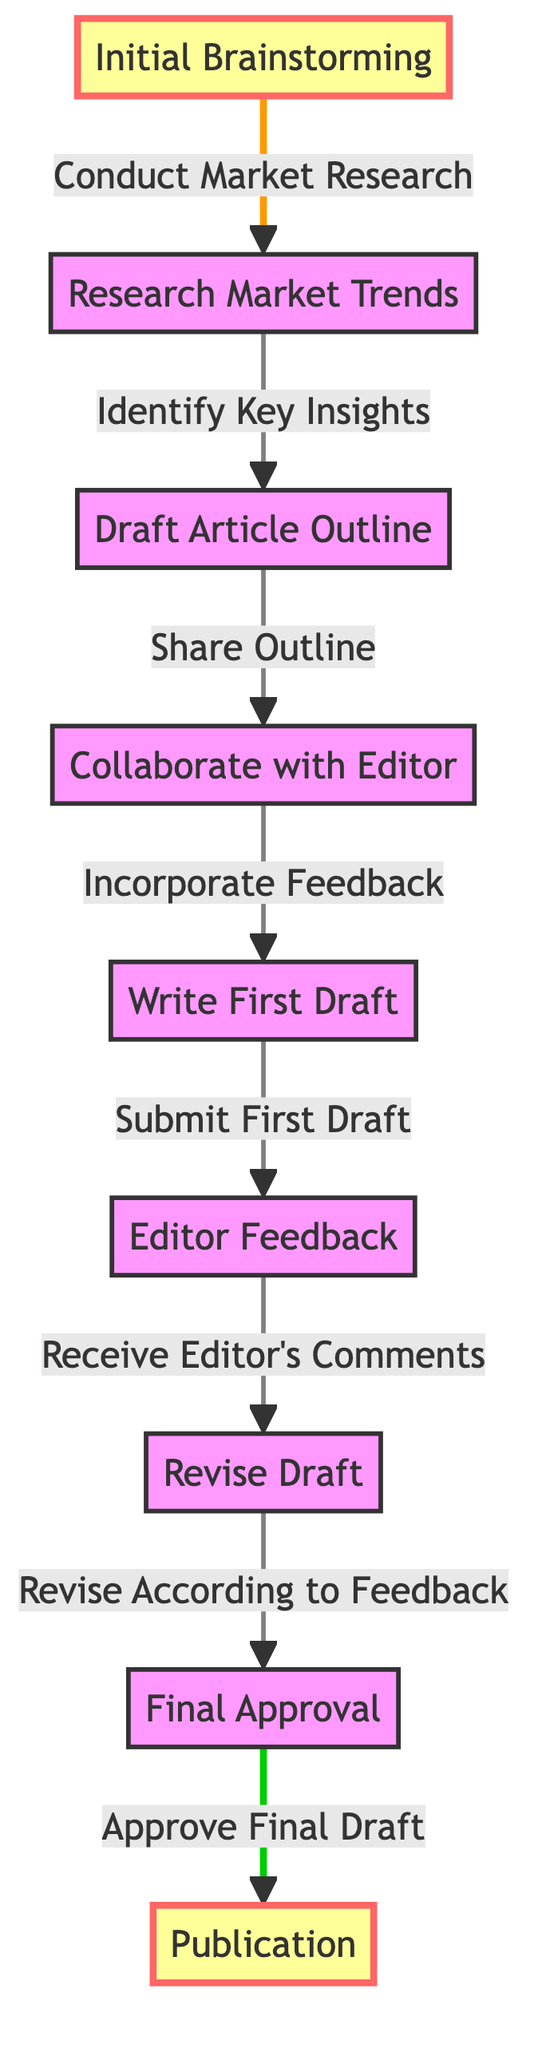What is the first stage in the collaboration process? The diagram starts with "Initial Brainstorming," which is labeled as the first stage in the process.
Answer: Initial Brainstorming How many main stages are depicted in the diagram? By counting the nodes from "Initial Brainstorming" to "Publication," we find that there are 9 main stages depicted in the flowchart.
Answer: 9 What action follows "Draft Article Outline"? The action that follows "Draft Article Outline" is "Share Outline" according to the flow of the diagram.
Answer: Share Outline What feedback action occurs after "Submit First Draft"? After "Submit First Draft," the feedback action that occurs is "Editor Feedback," demonstrating the iterative nature of the process.
Answer: Editor Feedback Which two stages are highlighted in the diagram? The two highlighted stages in the diagram are "Initial Brainstorming" and "Publication," indicating their significance in the collaboration flow.
Answer: Initial Brainstorming, Publication What is the final step before "Publication"? The final step before "Publication" is "Approve Final Draft," which must be completed before the article can be published.
Answer: Approve Final Draft Which stage requires revising the draft according to feedback? The stage that requires revising the draft according to feedback is "Revise According to Feedback," showing the importance of incorporating editor comments.
Answer: Revise According to Feedback What is the relationship between "Collaborate with Editor" and "Incorporate Feedback"? "Collaborate with Editor" directly leads to "Incorporate Feedback," indicating that collaboration is key to receiving and using feedback effectively.
Answer: Directly leads to What stage directly follows "Revise Draft"? "Revise Draft" is followed directly by "Final Approval," illustrating the sequence of revisions leading up to final acceptance.
Answer: Final Approval 